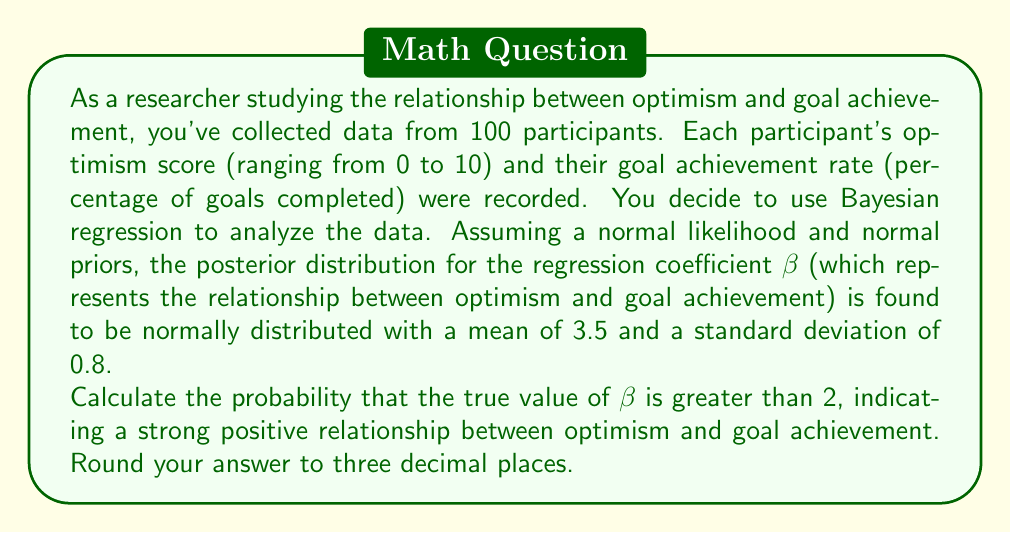Can you solve this math problem? To solve this problem, we need to use the properties of the normal distribution and standardize our variable of interest. Let's break it down step-by-step:

1) We're given that the posterior distribution of β is normal with:
   μ = 3.5 (mean)
   σ = 0.8 (standard deviation)

2) We want to find P(β > 2), which is equivalent to finding the area under the normal curve to the right of 2.

3) To use the standard normal distribution (Z-score), we need to standardize the value 2:

   $$Z = \frac{X - μ}{σ} = \frac{2 - 3.5}{0.8} = -1.875$$

4) Now, we need to find P(Z > -1.875) in the standard normal distribution.

5) This is equivalent to 1 - P(Z < -1.875), as the total area under the curve is 1.

6) Using a standard normal table or a statistical calculator, we can find:
   P(Z < -1.875) ≈ 0.0304

7) Therefore, P(Z > -1.875) = 1 - 0.0304 = 0.9696

This result aligns with the persona of a compassionate, optimistic individual, as it suggests a high probability of a strong positive relationship between optimism and goal achievement.
Answer: 0.970 